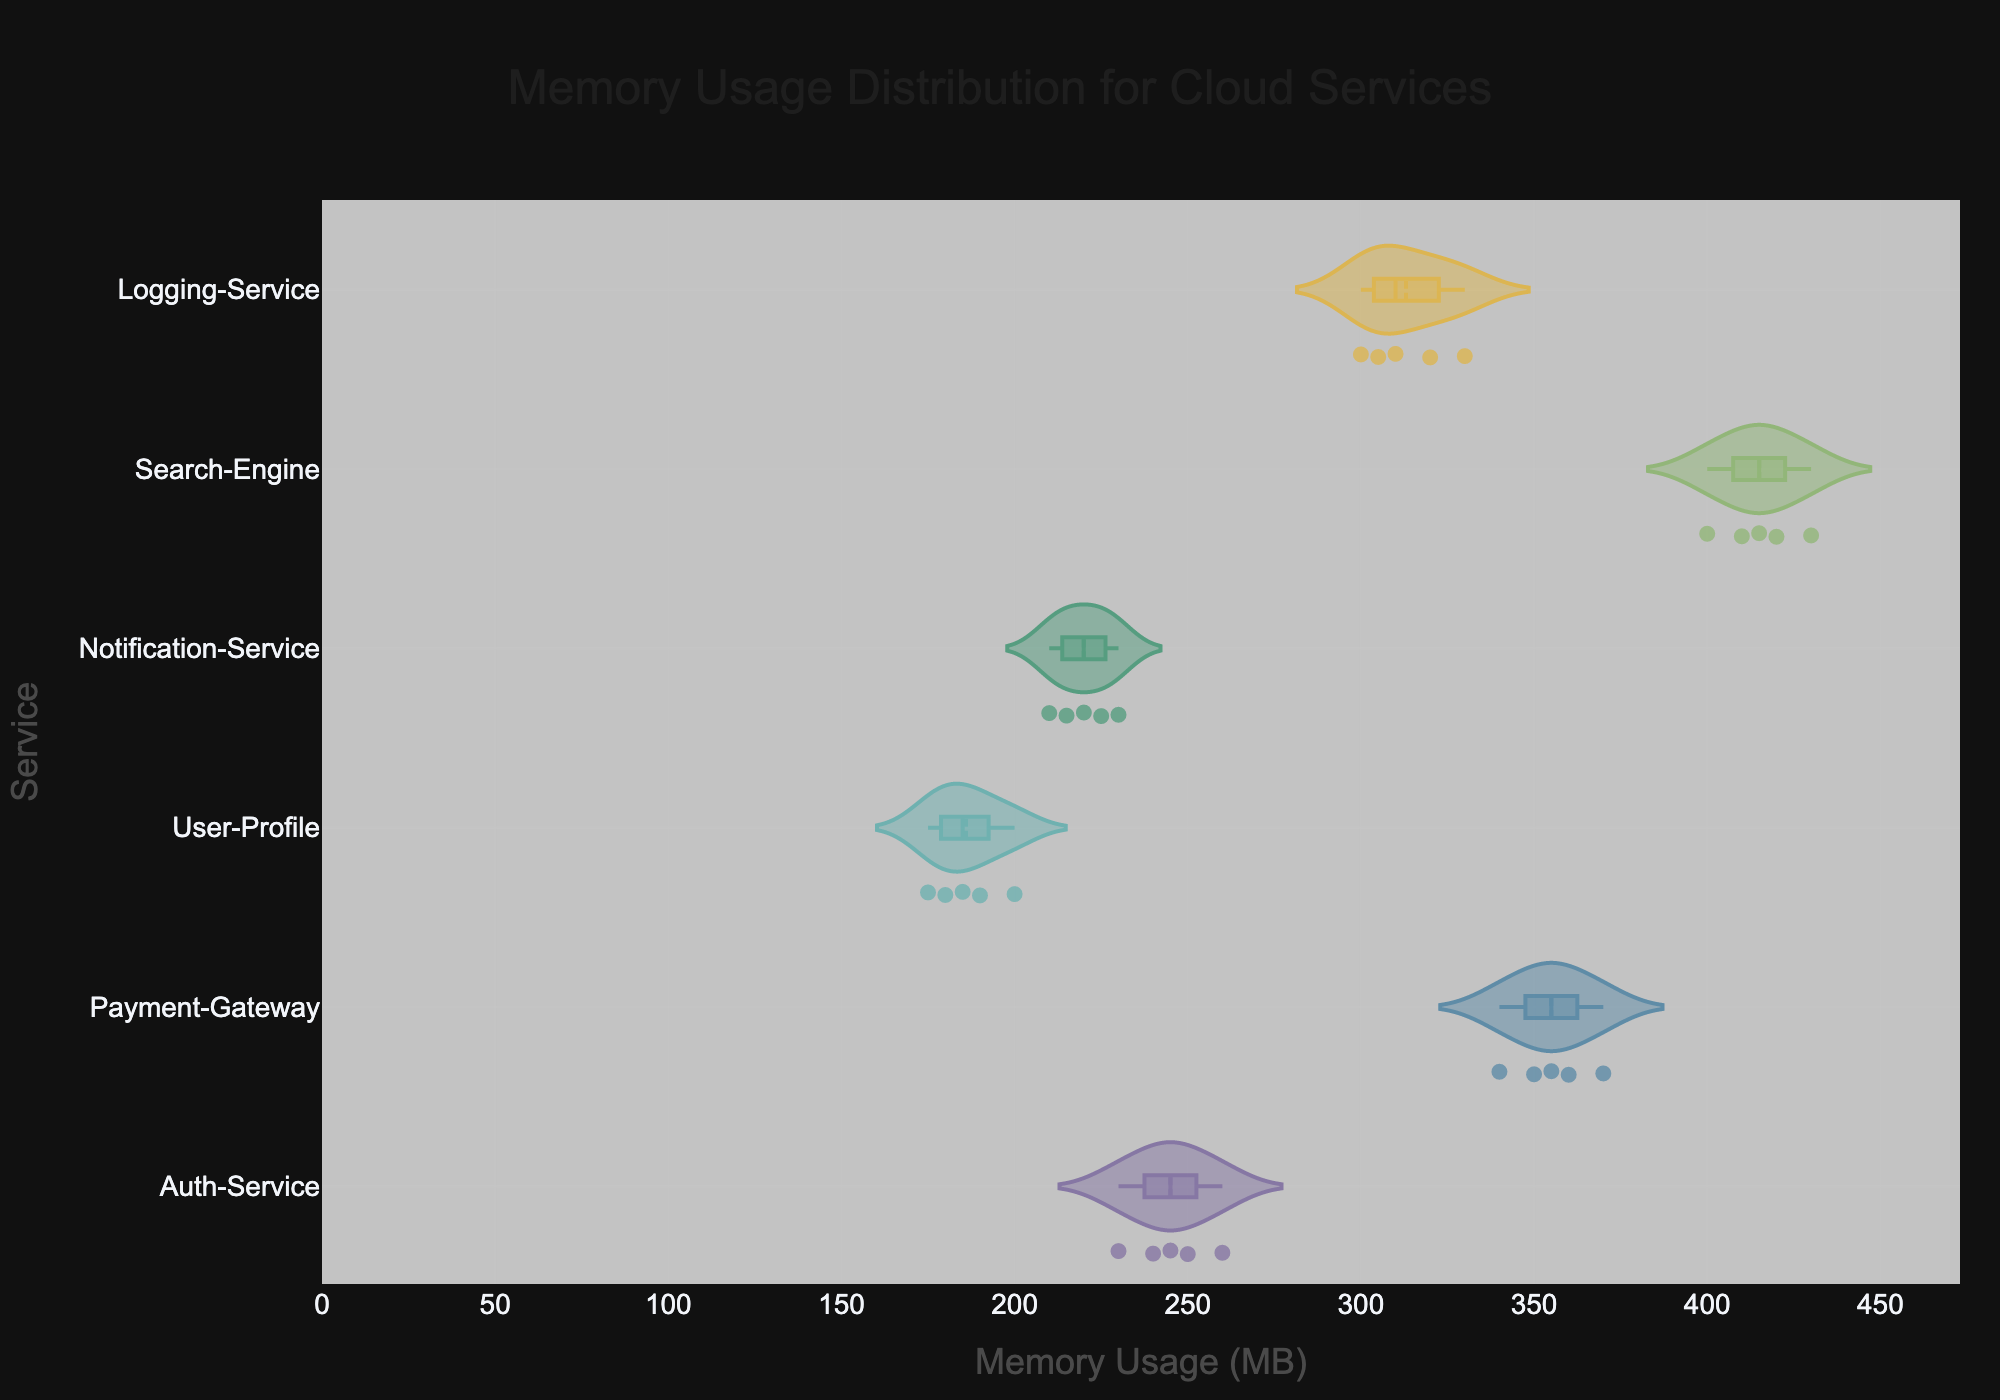what is the title of the figure? The title of a figure is typically found at the top and summarizes the content or objective of the figure. In this case, the content focuses on the memory usage distribution of different cloud services.
Answer: Memory Usage Distribution for Cloud Services What is the memory usage range for Payment-Gateway service? To determine the range, we look at the minimum and maximum memory usage values for the Payment-Gateway service. The minimum usage is 340 MB, and the maximum is 370 MB, so the range is 370 MB - 340 MB = 30 MB.
Answer: 30 MB Which service has the highest median memory usage? In a violin plot, the median value is often indicated by a line within the 'violin' shape. By visually comparing the median lines for all services, the highest one corresponds to the Search-Engine service.
Answer: Search-Engine What's the mean memory usage of the Auth-Service? To find the mean memory usage, sum up the memory usages (240, 250, 230, 260, 245) and divide by the number of data points. The mean is (240 + 250 + 230 + 260 + 245) / 5 = 245 MB.
Answer: 245 MB How many data points are there for the Notification-Service? Each dot within the violin plot represents a data point for a given service. By counting the dots in the violin for Notification-Service, there are 5 data points.
Answer: 5 Which service has the least variation in memory usage? Variation can be observed by the width of the violin plot. The narrower the violin, the less variation it has. By comparing the widths, User-Profile appears to have the least variation.
Answer: User-Profile Compare the mean memory usage between Auth-Service and Logging-Service. For each service, the mean value is visually represented in the violin plot typically as the center of the distribution. By comparing, Auth-Service has a mean of 245 MB, and Logging-Service has a mean of (300+310+320+330+305)/5 = 313 MB. So, Logging-Service has a higher mean.
Answer: Logging-Service What's the interquartile range (IQR) for the Search-Engine’s memory usage? First, identify the 25th percentile (Q1) and 75th percentile (Q3) on the violin plot. These values for Search-Engine are around 405 MB and 425 MB respectively. Hence, IQR = Q3 - Q1 = 425 - 405 = 20 MB.
Answer: 20 MB Which service shows the highest maximum memory usage? The maximum usages are represented by the highest points within each violin plot. By visually comparing, the Search-Engine service has the highest maximum memory usage at 430 MB
Answer: Search-Engine Does the Notification-Service's memory usage overlap with the User-Profile's? By comparing the horizontal extent of the violin plots of both services, we see that Notification-Service ranges from 210 to 230 MB and User-Profile ranges from 175 to 200 MB. Given these ranges, there is no overlap in their memory usage.
Answer: No 